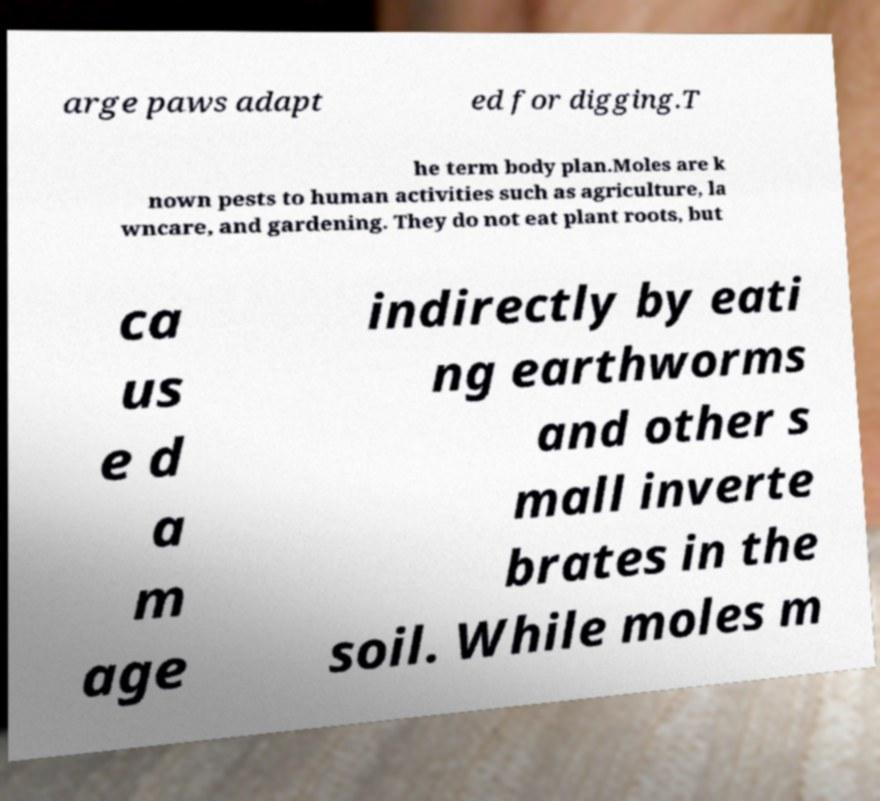Can you read and provide the text displayed in the image?This photo seems to have some interesting text. Can you extract and type it out for me? arge paws adapt ed for digging.T he term body plan.Moles are k nown pests to human activities such as agriculture, la wncare, and gardening. They do not eat plant roots, but ca us e d a m age indirectly by eati ng earthworms and other s mall inverte brates in the soil. While moles m 